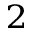Convert formula to latex. <formula><loc_0><loc_0><loc_500><loc_500>^ { 2 }</formula> 